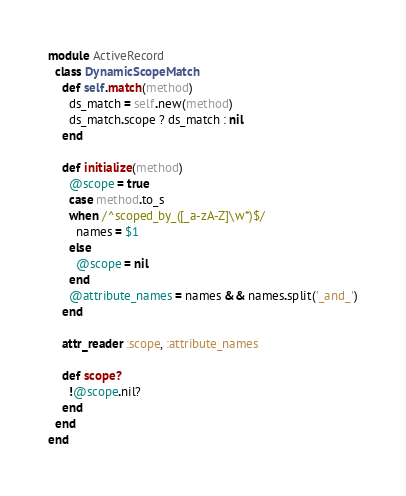Convert code to text. <code><loc_0><loc_0><loc_500><loc_500><_Ruby_>module ActiveRecord
  class DynamicScopeMatch
    def self.match(method)
      ds_match = self.new(method)
      ds_match.scope ? ds_match : nil
    end

    def initialize(method)
      @scope = true
      case method.to_s
      when /^scoped_by_([_a-zA-Z]\w*)$/
        names = $1
      else
        @scope = nil
      end
      @attribute_names = names && names.split('_and_')
    end

    attr_reader :scope, :attribute_names

    def scope?
      !@scope.nil?
    end
  end
end
</code> 